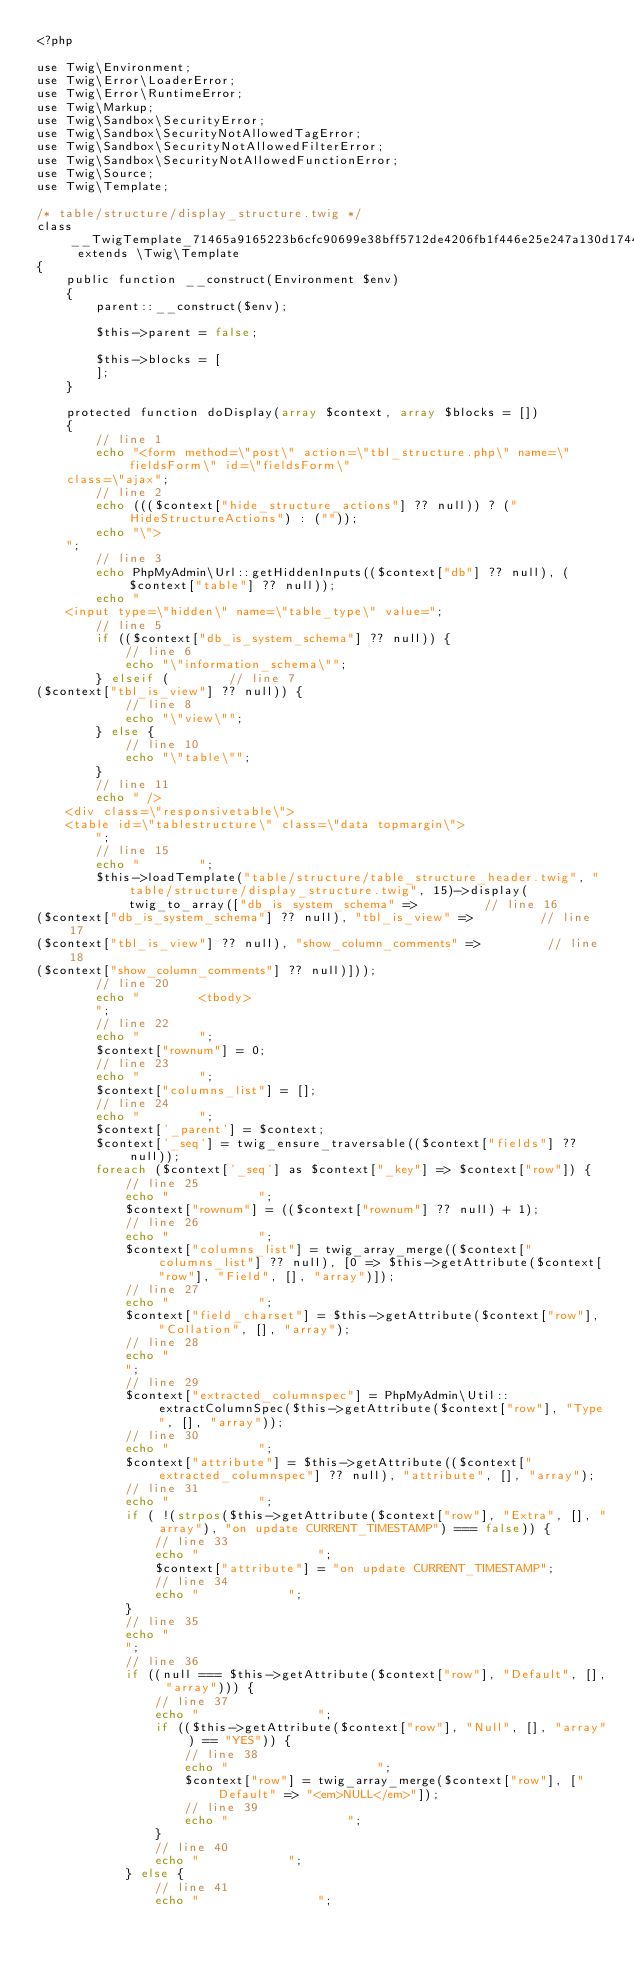Convert code to text. <code><loc_0><loc_0><loc_500><loc_500><_PHP_><?php

use Twig\Environment;
use Twig\Error\LoaderError;
use Twig\Error\RuntimeError;
use Twig\Markup;
use Twig\Sandbox\SecurityError;
use Twig\Sandbox\SecurityNotAllowedTagError;
use Twig\Sandbox\SecurityNotAllowedFilterError;
use Twig\Sandbox\SecurityNotAllowedFunctionError;
use Twig\Source;
use Twig\Template;

/* table/structure/display_structure.twig */
class __TwigTemplate_71465a9165223b6cfc90699e38bff5712de4206fb1f446e25e247a130d174486 extends \Twig\Template
{
    public function __construct(Environment $env)
    {
        parent::__construct($env);

        $this->parent = false;

        $this->blocks = [
        ];
    }

    protected function doDisplay(array $context, array $blocks = [])
    {
        // line 1
        echo "<form method=\"post\" action=\"tbl_structure.php\" name=\"fieldsForm\" id=\"fieldsForm\"
    class=\"ajax";
        // line 2
        echo ((($context["hide_structure_actions"] ?? null)) ? (" HideStructureActions") : (""));
        echo "\">
    ";
        // line 3
        echo PhpMyAdmin\Url::getHiddenInputs(($context["db"] ?? null), ($context["table"] ?? null));
        echo "
    <input type=\"hidden\" name=\"table_type\" value=";
        // line 5
        if (($context["db_is_system_schema"] ?? null)) {
            // line 6
            echo "\"information_schema\"";
        } elseif (        // line 7
($context["tbl_is_view"] ?? null)) {
            // line 8
            echo "\"view\"";
        } else {
            // line 10
            echo "\"table\"";
        }
        // line 11
        echo " />
    <div class=\"responsivetable\">
    <table id=\"tablestructure\" class=\"data topmargin\">
        ";
        // line 15
        echo "        ";
        $this->loadTemplate("table/structure/table_structure_header.twig", "table/structure/display_structure.twig", 15)->display(twig_to_array(["db_is_system_schema" =>         // line 16
($context["db_is_system_schema"] ?? null), "tbl_is_view" =>         // line 17
($context["tbl_is_view"] ?? null), "show_column_comments" =>         // line 18
($context["show_column_comments"] ?? null)]));
        // line 20
        echo "        <tbody>
        ";
        // line 22
        echo "        ";
        $context["rownum"] = 0;
        // line 23
        echo "        ";
        $context["columns_list"] = [];
        // line 24
        echo "        ";
        $context['_parent'] = $context;
        $context['_seq'] = twig_ensure_traversable(($context["fields"] ?? null));
        foreach ($context['_seq'] as $context["_key"] => $context["row"]) {
            // line 25
            echo "            ";
            $context["rownum"] = (($context["rownum"] ?? null) + 1);
            // line 26
            echo "            ";
            $context["columns_list"] = twig_array_merge(($context["columns_list"] ?? null), [0 => $this->getAttribute($context["row"], "Field", [], "array")]);
            // line 27
            echo "            ";
            $context["field_charset"] = $this->getAttribute($context["row"], "Collation", [], "array");
            // line 28
            echo "
            ";
            // line 29
            $context["extracted_columnspec"] = PhpMyAdmin\Util::extractColumnSpec($this->getAttribute($context["row"], "Type", [], "array"));
            // line 30
            echo "            ";
            $context["attribute"] = $this->getAttribute(($context["extracted_columnspec"] ?? null), "attribute", [], "array");
            // line 31
            echo "            ";
            if ( !(strpos($this->getAttribute($context["row"], "Extra", [], "array"), "on update CURRENT_TIMESTAMP") === false)) {
                // line 33
                echo "                ";
                $context["attribute"] = "on update CURRENT_TIMESTAMP";
                // line 34
                echo "            ";
            }
            // line 35
            echo "
            ";
            // line 36
            if ((null === $this->getAttribute($context["row"], "Default", [], "array"))) {
                // line 37
                echo "                ";
                if (($this->getAttribute($context["row"], "Null", [], "array") == "YES")) {
                    // line 38
                    echo "                    ";
                    $context["row"] = twig_array_merge($context["row"], ["Default" => "<em>NULL</em>"]);
                    // line 39
                    echo "                ";
                }
                // line 40
                echo "            ";
            } else {
                // line 41
                echo "                ";</code> 